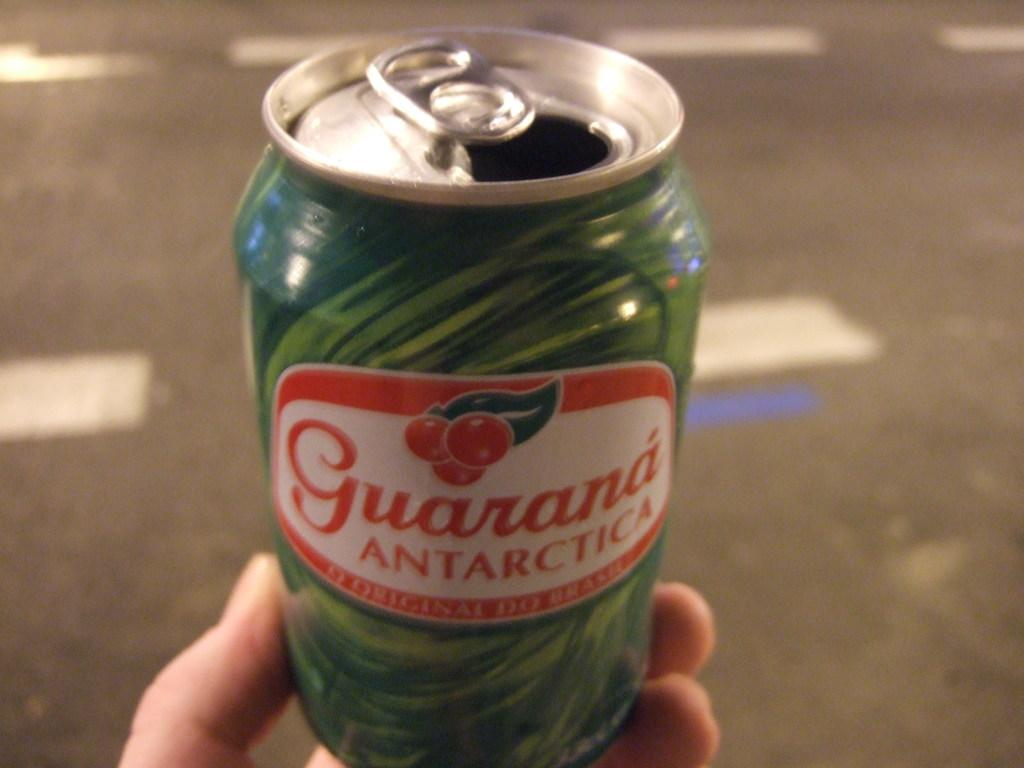What is the person holding in the image? There is a hand holding a tin in the image. What can be seen in the background of the image? There is a road visible in the background of the image. What type of food is being prepared on the trains in the image? There are no trains present in the image, and therefore no food preparation can be observed. 